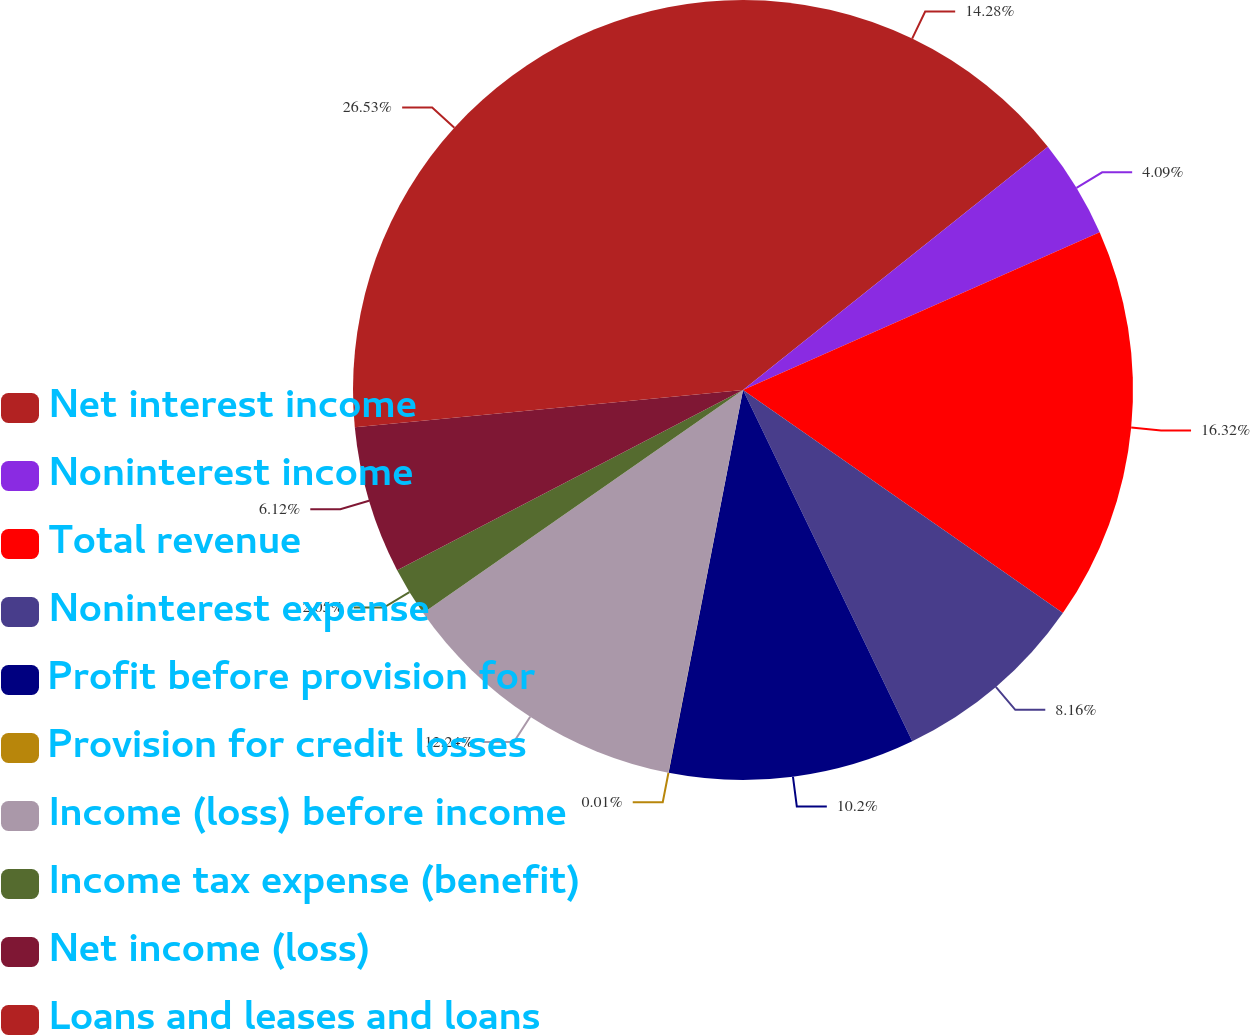<chart> <loc_0><loc_0><loc_500><loc_500><pie_chart><fcel>Net interest income<fcel>Noninterest income<fcel>Total revenue<fcel>Noninterest expense<fcel>Profit before provision for<fcel>Provision for credit losses<fcel>Income (loss) before income<fcel>Income tax expense (benefit)<fcel>Net income (loss)<fcel>Loans and leases and loans<nl><fcel>14.28%<fcel>4.09%<fcel>16.32%<fcel>8.16%<fcel>10.2%<fcel>0.01%<fcel>12.24%<fcel>2.05%<fcel>6.12%<fcel>26.52%<nl></chart> 